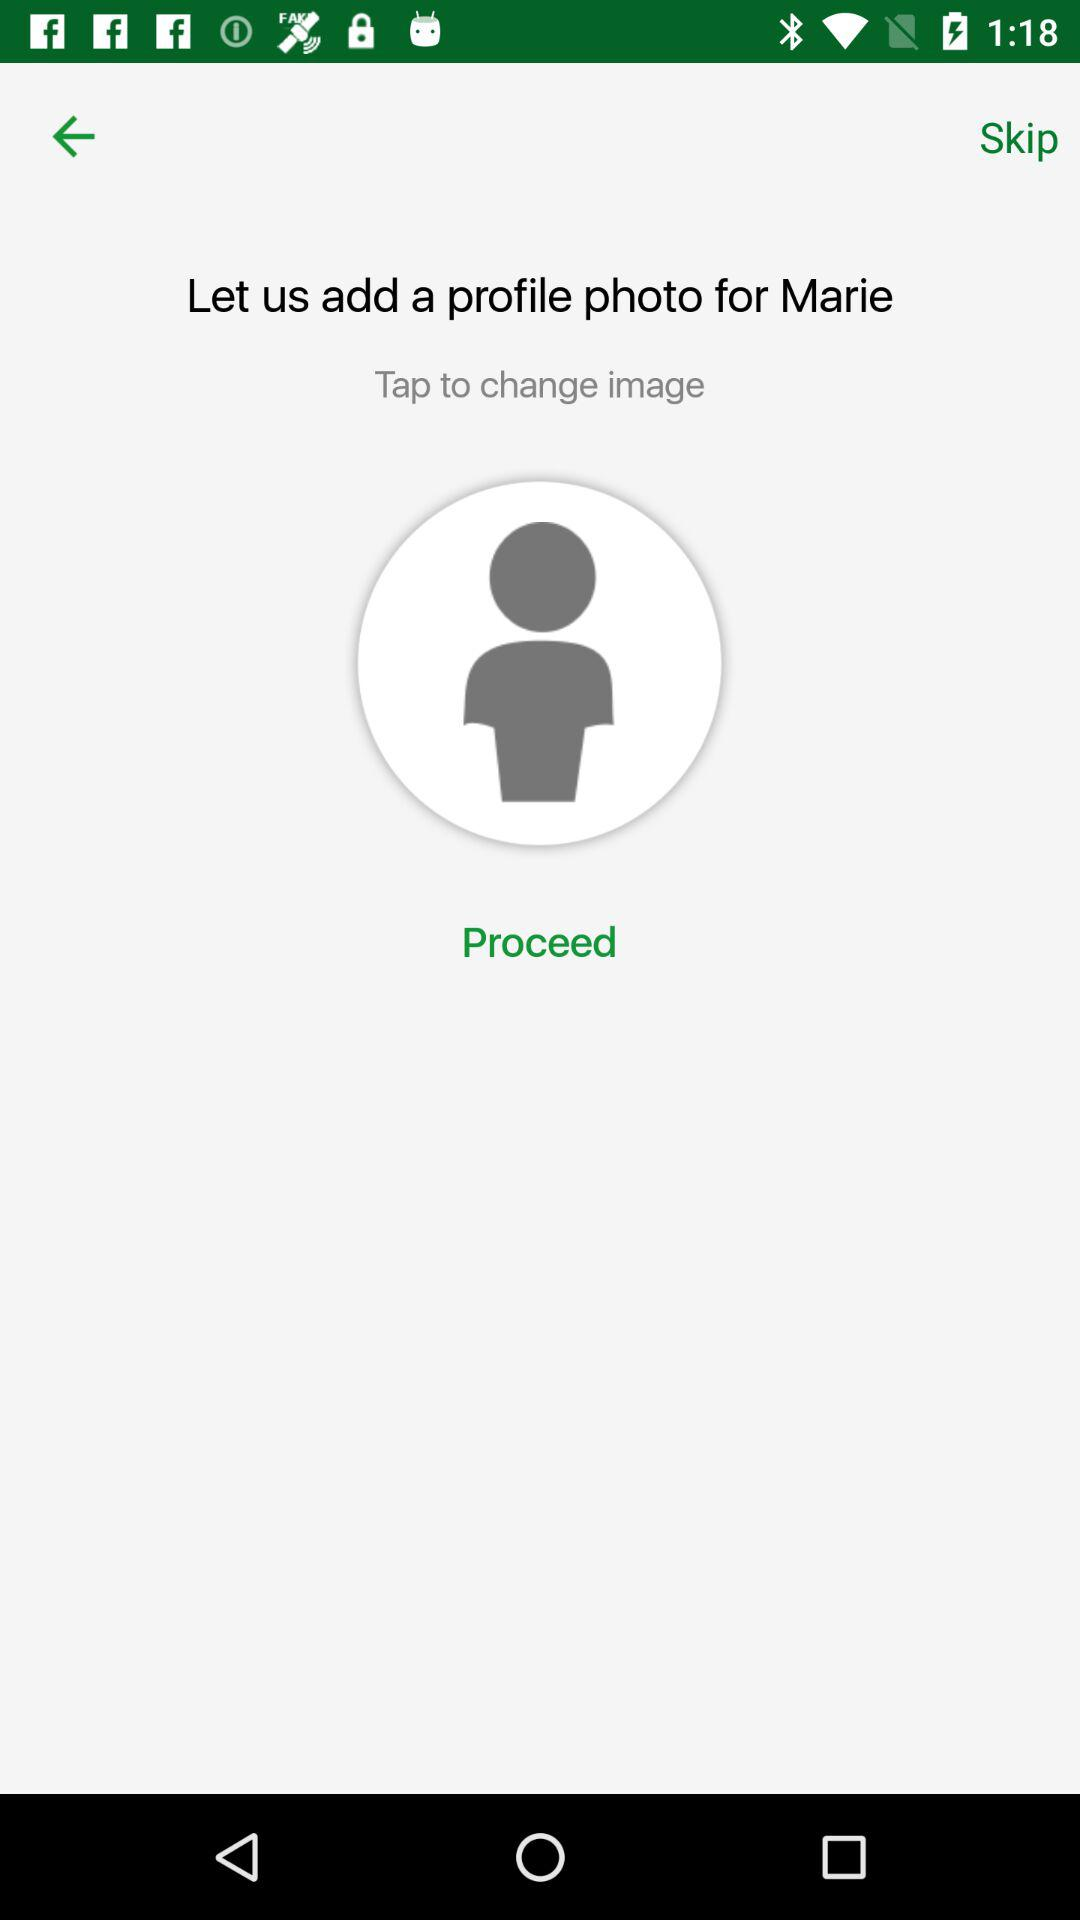What is the user name? The user name is Marie. 